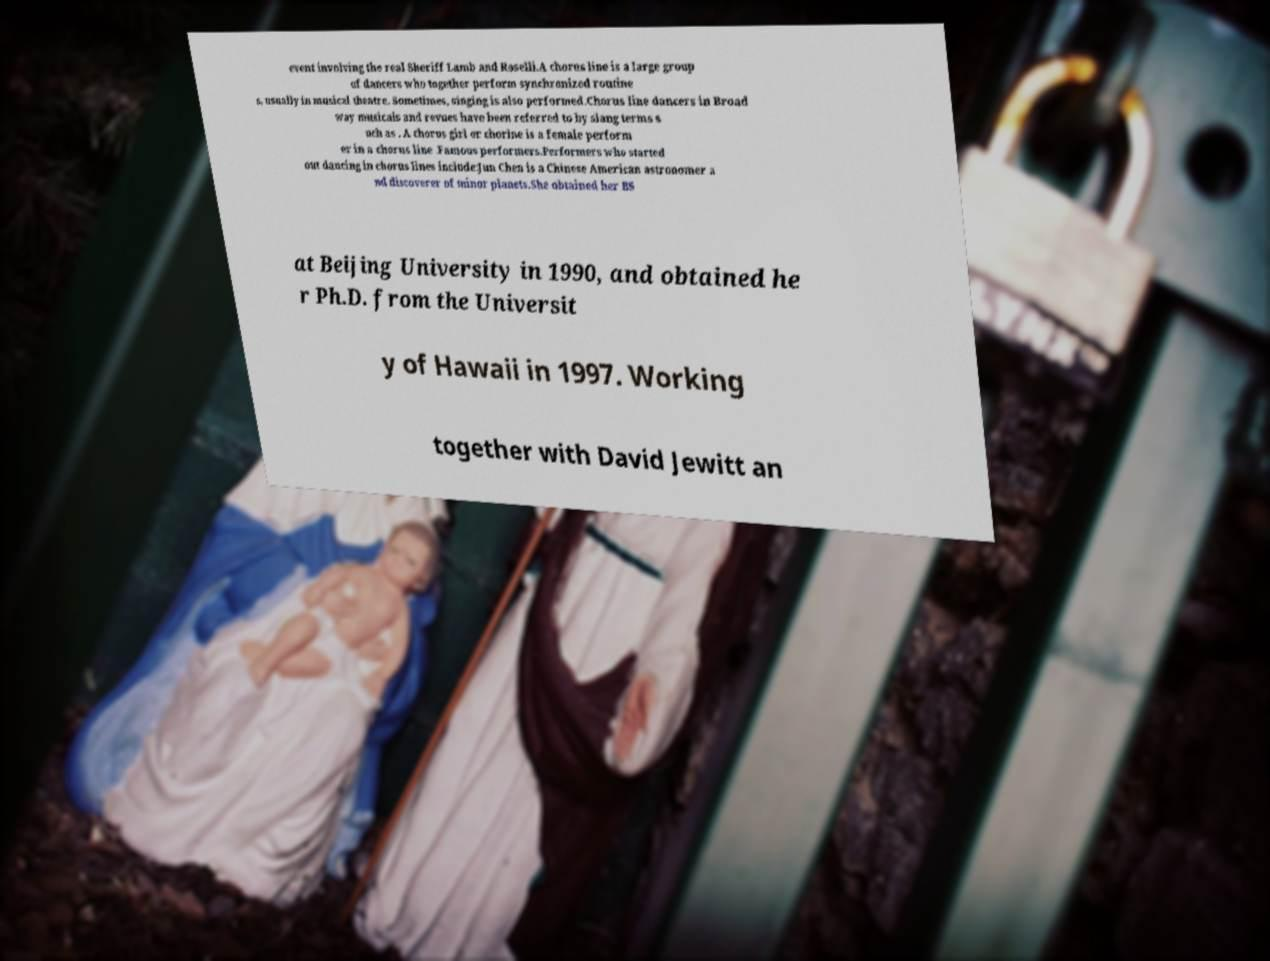Please read and relay the text visible in this image. What does it say? event involving the real Sheriff Lamb and Roselli.A chorus line is a large group of dancers who together perform synchronized routine s, usually in musical theatre. Sometimes, singing is also performed.Chorus line dancers in Broad way musicals and revues have been referred to by slang terms s uch as . A chorus girl or chorine is a female perform er in a chorus line .Famous performers.Performers who started out dancing in chorus lines include:Jun Chen is a Chinese American astronomer a nd discoverer of minor planets.She obtained her BS at Beijing University in 1990, and obtained he r Ph.D. from the Universit y of Hawaii in 1997. Working together with David Jewitt an 